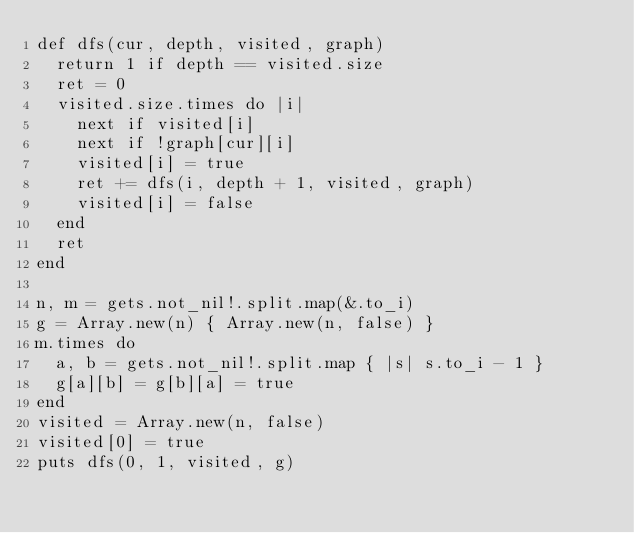<code> <loc_0><loc_0><loc_500><loc_500><_Crystal_>def dfs(cur, depth, visited, graph)
  return 1 if depth == visited.size
  ret = 0
  visited.size.times do |i|
    next if visited[i]
    next if !graph[cur][i]
    visited[i] = true
    ret += dfs(i, depth + 1, visited, graph)
    visited[i] = false
  end
  ret
end

n, m = gets.not_nil!.split.map(&.to_i)
g = Array.new(n) { Array.new(n, false) }
m.times do
  a, b = gets.not_nil!.split.map { |s| s.to_i - 1 }
  g[a][b] = g[b][a] = true
end
visited = Array.new(n, false)
visited[0] = true
puts dfs(0, 1, visited, g)
</code> 